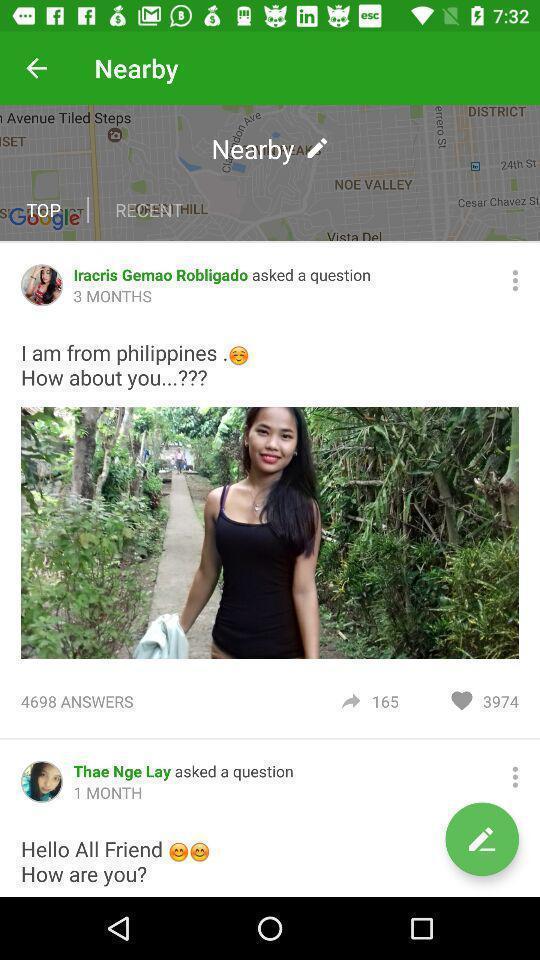Please provide a description for this image. Pop up displaying top questions. 